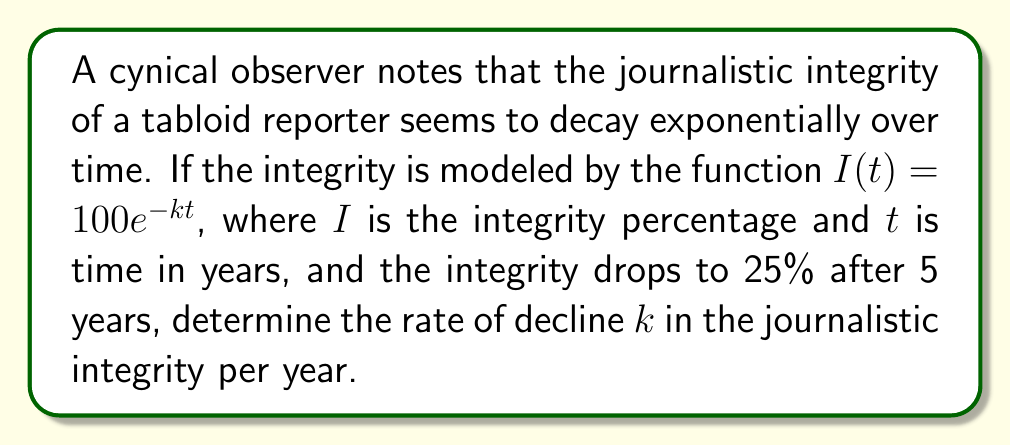Could you help me with this problem? 1) We are given the function $I(t) = 100e^{-kt}$, where:
   $I(t)$ is the integrity percentage at time $t$
   $100$ is the initial integrity percentage
   $k$ is the rate of decline (what we need to find)
   $t$ is the time in years

2) We know that after 5 years $(t=5)$, the integrity is 25% $(I(5)=25)$

3) Let's substitute these values into the equation:
   $25 = 100e^{-k(5)}$

4) Divide both sides by 100:
   $\frac{25}{100} = e^{-5k}$
   $0.25 = e^{-5k}$

5) Take the natural logarithm of both sides:
   $\ln(0.25) = \ln(e^{-5k})$
   $\ln(0.25) = -5k$

6) Solve for $k$:
   $k = -\frac{\ln(0.25)}{5}$

7) Calculate the value:
   $k = -\frac{\ln(0.25)}{5} \approx 0.2773$ per year

Thus, the rate of decline in journalistic integrity is approximately 0.2773 or 27.73% per year.
Answer: $k \approx 0.2773$ per year 